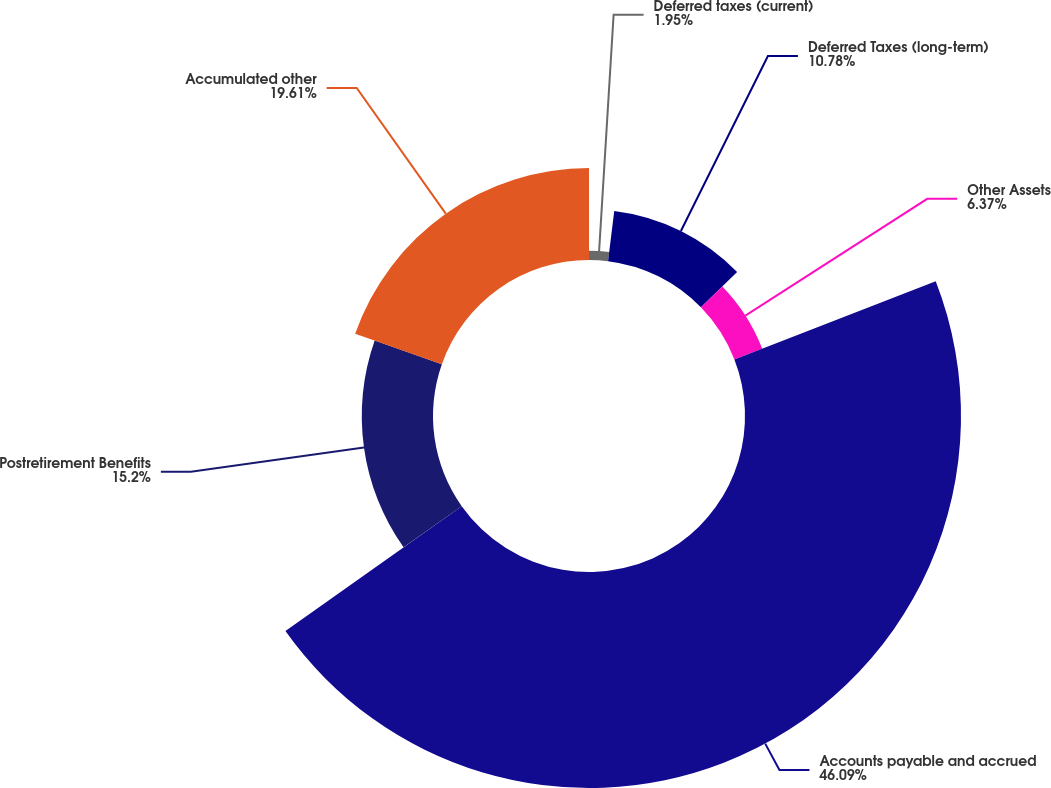Convert chart to OTSL. <chart><loc_0><loc_0><loc_500><loc_500><pie_chart><fcel>Deferred taxes (current)<fcel>Deferred Taxes (long-term)<fcel>Other Assets<fcel>Accounts payable and accrued<fcel>Postretirement Benefits<fcel>Accumulated other<nl><fcel>1.95%<fcel>10.78%<fcel>6.37%<fcel>46.09%<fcel>15.2%<fcel>19.61%<nl></chart> 